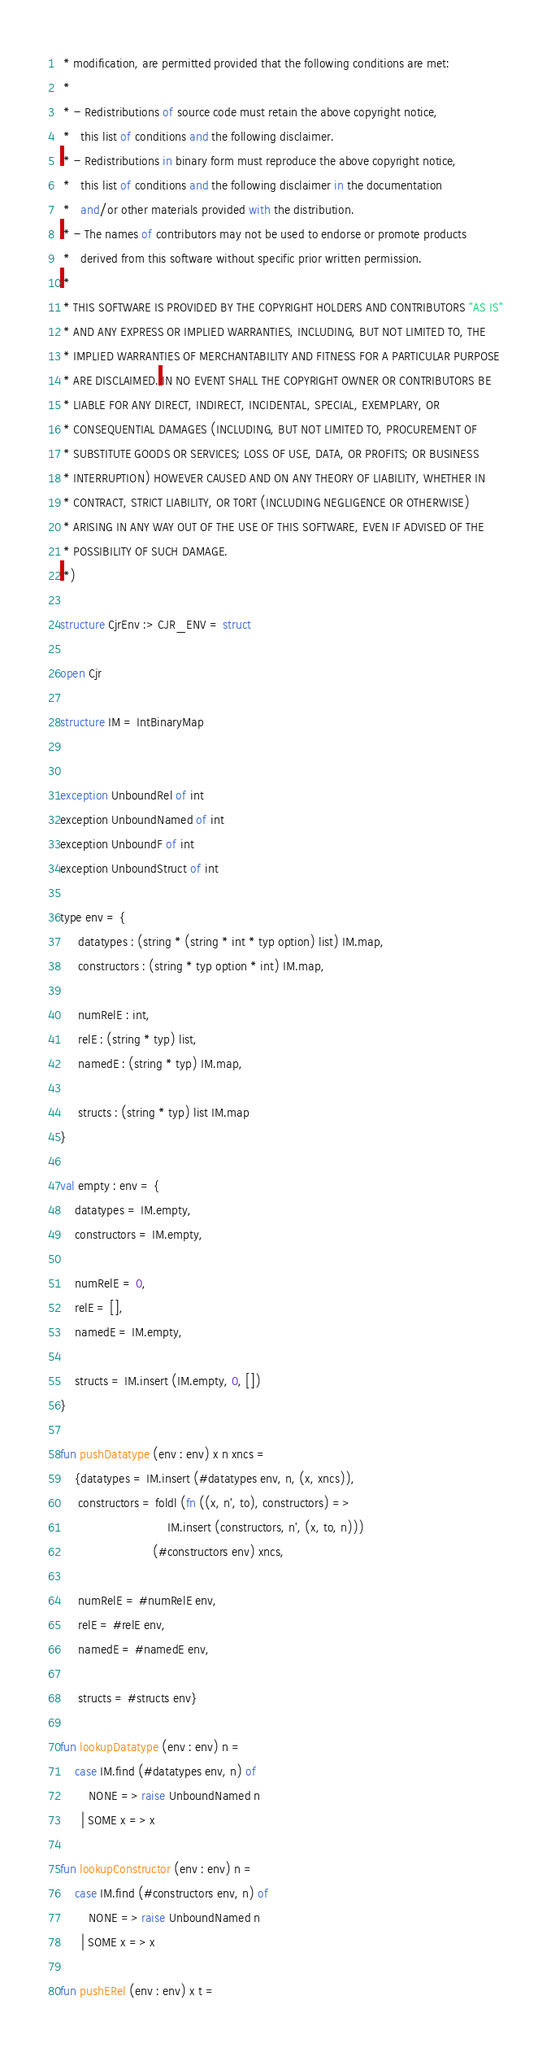<code> <loc_0><loc_0><loc_500><loc_500><_SML_> * modification, are permitted provided that the following conditions are met:
 *
 * - Redistributions of source code must retain the above copyright notice,
 *   this list of conditions and the following disclaimer.
 * - Redistributions in binary form must reproduce the above copyright notice,
 *   this list of conditions and the following disclaimer in the documentation
 *   and/or other materials provided with the distribution.
 * - The names of contributors may not be used to endorse or promote products
 *   derived from this software without specific prior written permission.
 *
 * THIS SOFTWARE IS PROVIDED BY THE COPYRIGHT HOLDERS AND CONTRIBUTORS "AS IS"
 * AND ANY EXPRESS OR IMPLIED WARRANTIES, INCLUDING, BUT NOT LIMITED TO, THE
 * IMPLIED WARRANTIES OF MERCHANTABILITY AND FITNESS FOR A PARTICULAR PURPOSE
 * ARE DISCLAIMED. IN NO EVENT SHALL THE COPYRIGHT OWNER OR CONTRIBUTORS BE
 * LIABLE FOR ANY DIRECT, INDIRECT, INCIDENTAL, SPECIAL, EXEMPLARY, OR 
 * CONSEQUENTIAL DAMAGES (INCLUDING, BUT NOT LIMITED TO, PROCUREMENT OF
 * SUBSTITUTE GOODS OR SERVICES; LOSS OF USE, DATA, OR PROFITS; OR BUSINESS
 * INTERRUPTION) HOWEVER CAUSED AND ON ANY THEORY OF LIABILITY, WHETHER IN
 * CONTRACT, STRICT LIABILITY, OR TORT (INCLUDING NEGLIGENCE OR OTHERWISE)
 * ARISING IN ANY WAY OUT OF THE USE OF THIS SOFTWARE, EVEN IF ADVISED OF THE
 * POSSIBILITY OF SUCH DAMAGE.
 *)

structure CjrEnv :> CJR_ENV = struct

open Cjr

structure IM = IntBinaryMap


exception UnboundRel of int
exception UnboundNamed of int
exception UnboundF of int
exception UnboundStruct of int

type env = {
     datatypes : (string * (string * int * typ option) list) IM.map,
     constructors : (string * typ option * int) IM.map,

     numRelE : int,
     relE : (string * typ) list,
     namedE : (string * typ) IM.map,

     structs : (string * typ) list IM.map
}

val empty : env = {
    datatypes = IM.empty,
    constructors = IM.empty,

    numRelE = 0,
    relE = [],
    namedE = IM.empty,

    structs = IM.insert (IM.empty, 0, [])
}

fun pushDatatype (env : env) x n xncs =
    {datatypes = IM.insert (#datatypes env, n, (x, xncs)),
     constructors = foldl (fn ((x, n', to), constructors) =>
                              IM.insert (constructors, n', (x, to, n)))
                          (#constructors env) xncs,

     numRelE = #numRelE env,
     relE = #relE env,
     namedE = #namedE env,

     structs = #structs env}

fun lookupDatatype (env : env) n =
    case IM.find (#datatypes env, n) of
        NONE => raise UnboundNamed n
      | SOME x => x

fun lookupConstructor (env : env) n =
    case IM.find (#constructors env, n) of
        NONE => raise UnboundNamed n
      | SOME x => x

fun pushERel (env : env) x t =</code> 